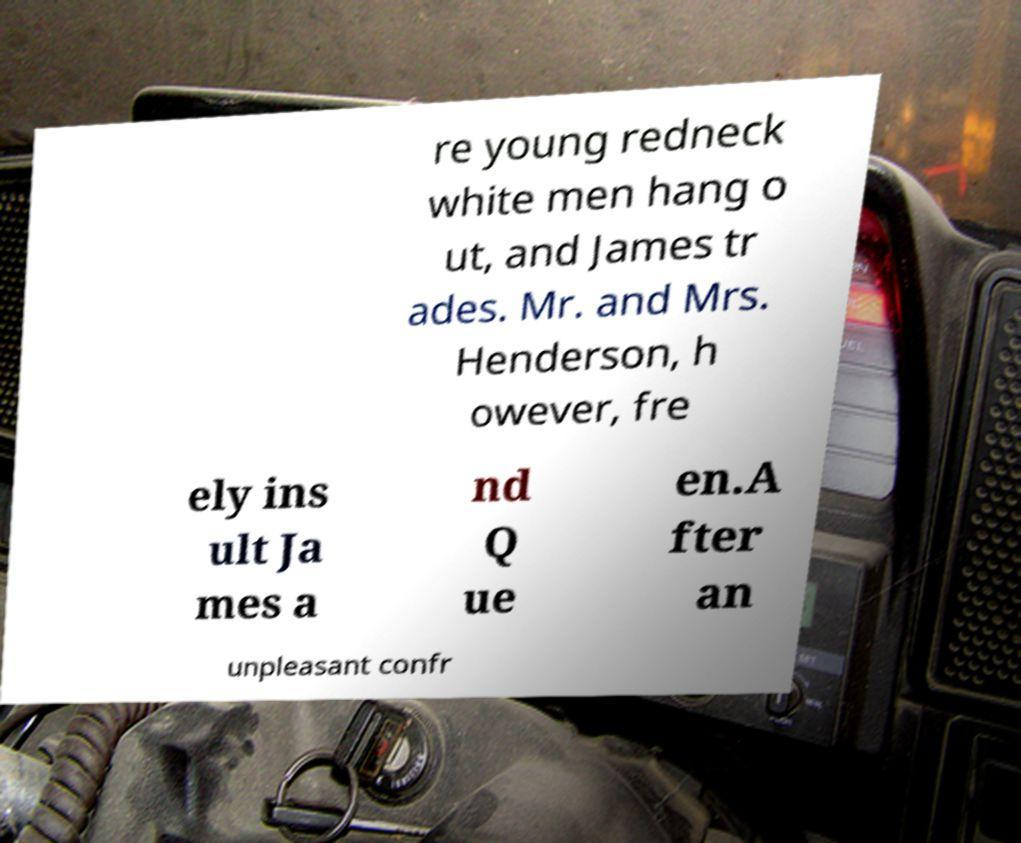For documentation purposes, I need the text within this image transcribed. Could you provide that? re young redneck white men hang o ut, and James tr ades. Mr. and Mrs. Henderson, h owever, fre ely ins ult Ja mes a nd Q ue en.A fter an unpleasant confr 